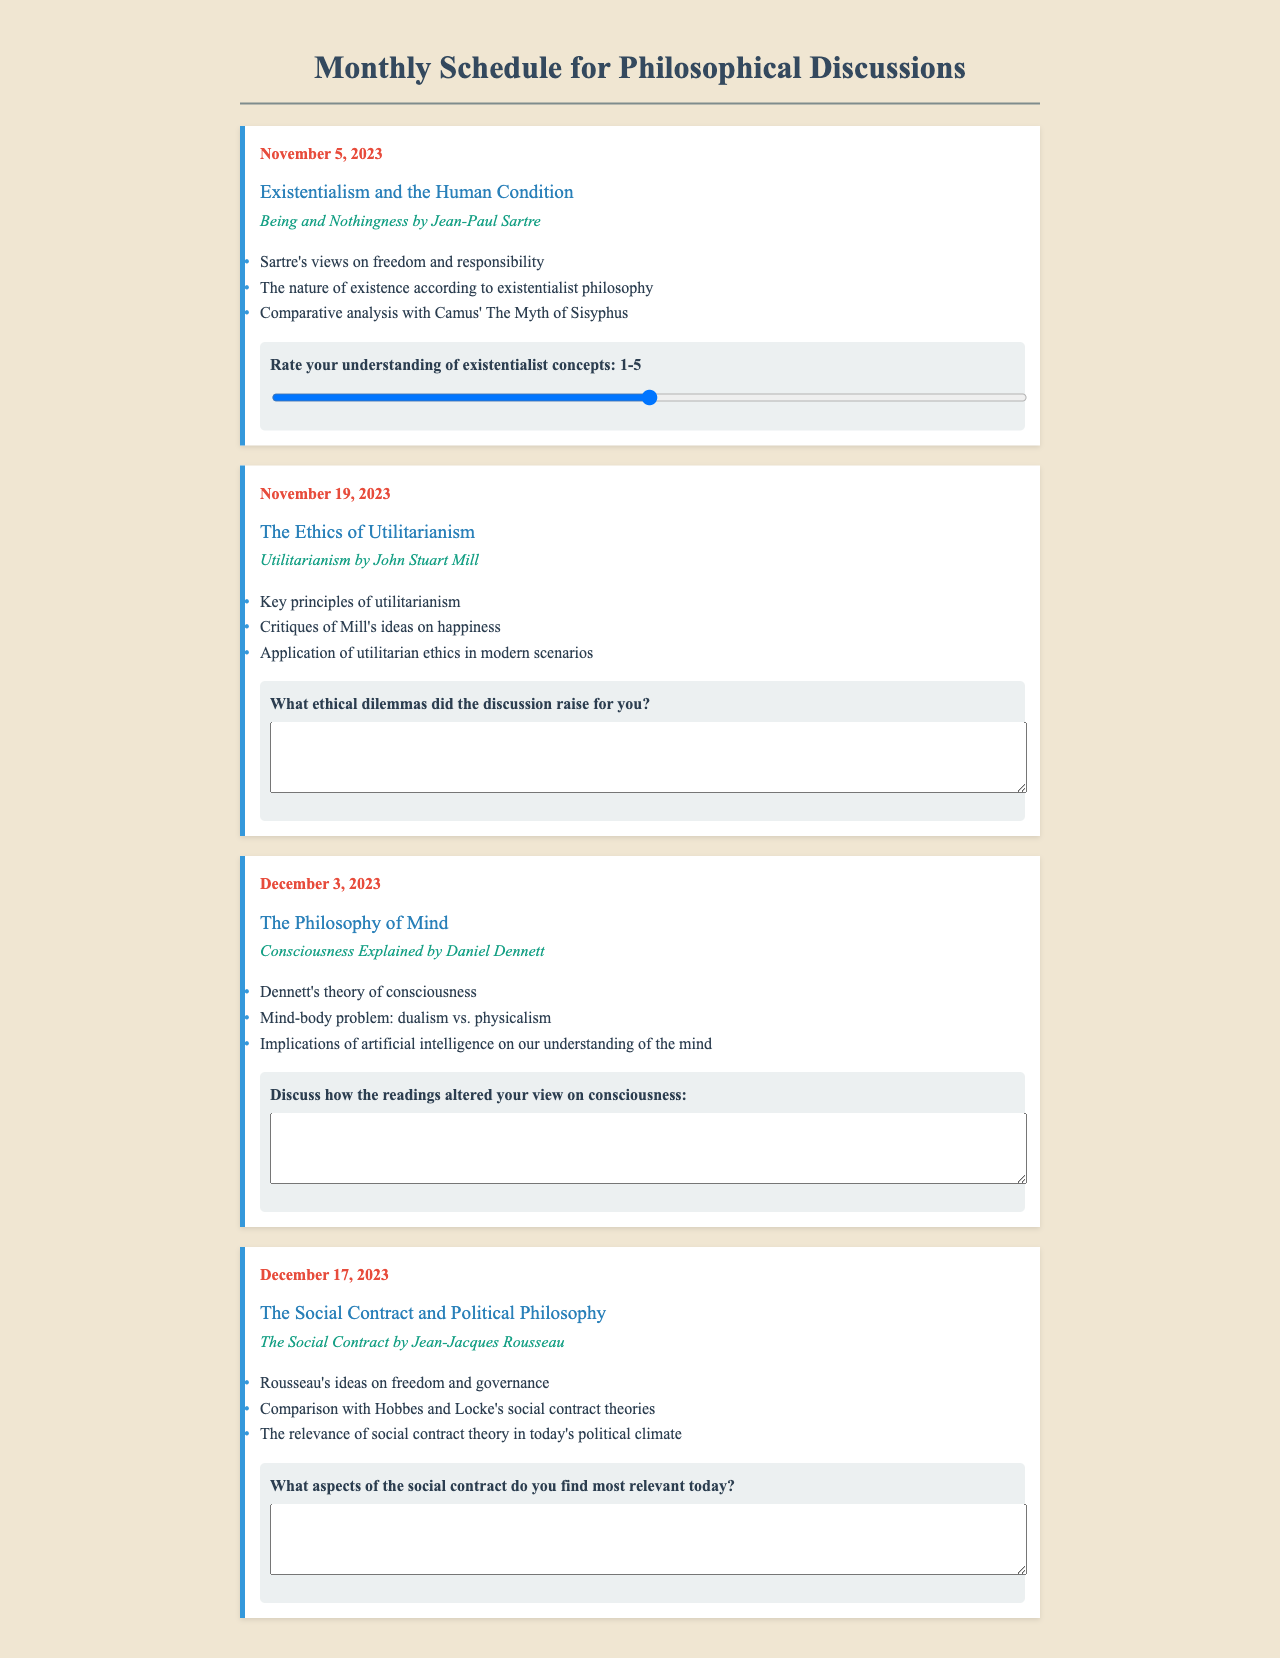What is the date for the discussion on Existentialism? The date for the Existentialism discussion is explicitly mentioned in the document as November 5, 2023.
Answer: November 5, 2023 What book is associated with the topic of Ethics of Utilitarianism? The book associated with the Ethics of Utilitarianism topic is explicitly listed in the document as "Utilitarianism" by John Stuart Mill.
Answer: Utilitarianism by John Stuart Mill What rating scale is used for understanding existentialist concepts? The document specifies a rating scale from 1 to 5 for understanding existentialist concepts.
Answer: 1-5 How many topics are scheduled for December 2023? There are two topics scheduled in December, as listed in the document for December 3 and December 17, 2023.
Answer: 2 What is the key theme of the discussion scheduled for December 17, 2023? The key theme for December 17, 2023, is explicitly stated in the document as "The Social Contract and Political Philosophy."
Answer: The Social Contract and Political Philosophy What does the feedback section for the discussion on Consciousness relate to? The feedback section for the Consciousness discussion asks participants to discuss how the readings altered their view on consciousness, indicating a reflective response.
Answer: How the readings altered your view on consciousness Which philosophical figure is discussed alongside Hobbes and Locke? The philosophical figure discussed alongside Hobbes and Locke in the context of social contract theory is Jean-Jacques Rousseau, as per the document's content.
Answer: Jean-Jacques Rousseau What color is used for the feedback background in the discussions? The feedback background color is described in the document as a shade of light gray, specifically "#ecf0f1".
Answer: Light gray What is the primary focus of Dennett's book mentioned in the schedule? The primary focus of Dennett's book mentioned in the schedule pertains to the theory of consciousness.
Answer: Theory of consciousness 